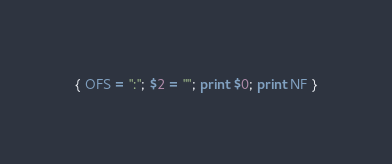<code> <loc_0><loc_0><loc_500><loc_500><_Awk_>{ OFS = ":"; $2 = ""; print $0; print NF }
</code> 